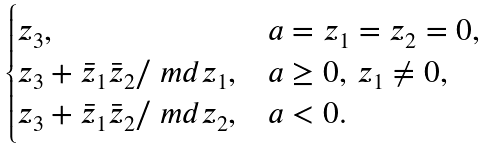<formula> <loc_0><loc_0><loc_500><loc_500>\begin{cases} z _ { 3 } , & a = z _ { 1 } = z _ { 2 } = 0 , \\ z _ { 3 } + \bar { z } _ { 1 } \bar { z } _ { 2 } / \ m d { z _ { 1 } } , & a \geq 0 , \, z _ { 1 } \ne 0 , \\ z _ { 3 } + \bar { z } _ { 1 } \bar { z } _ { 2 } / \ m d { z _ { 2 } } , & a < 0 . \end{cases}</formula> 